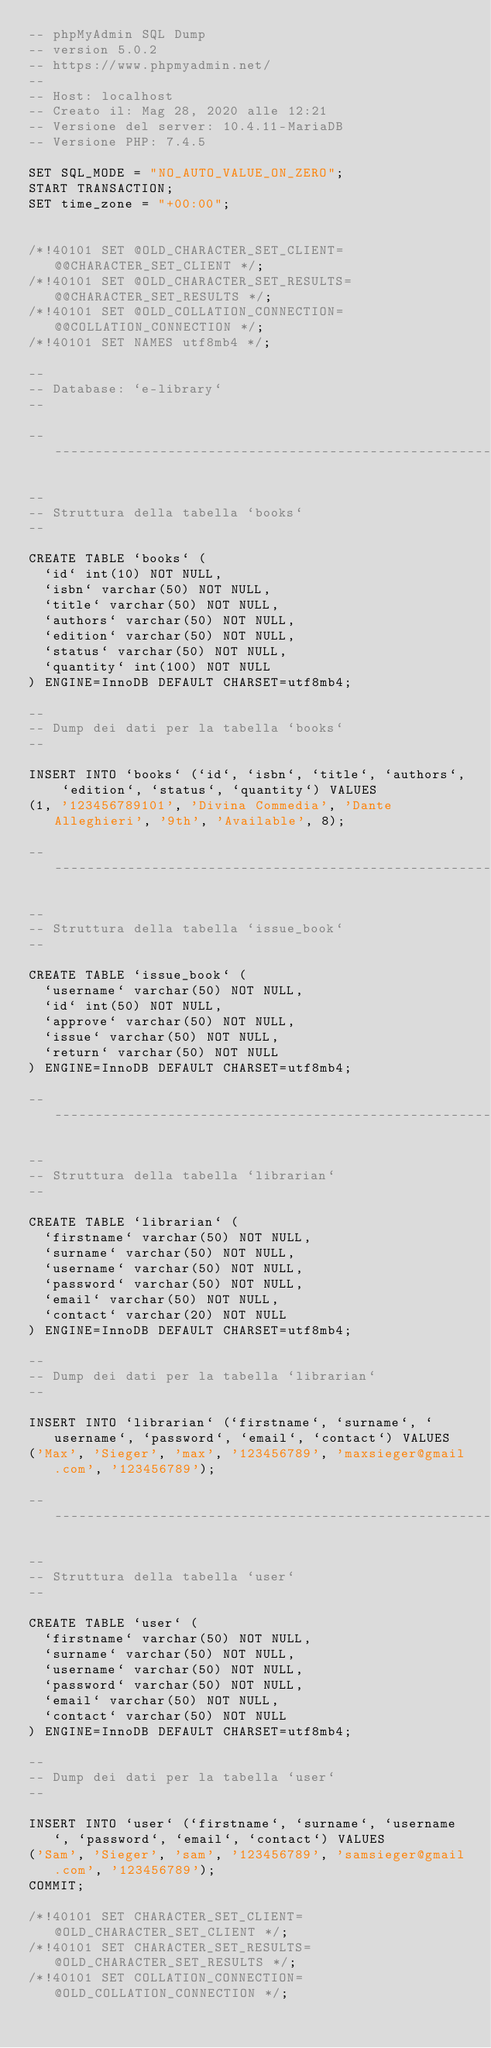Convert code to text. <code><loc_0><loc_0><loc_500><loc_500><_SQL_>-- phpMyAdmin SQL Dump
-- version 5.0.2
-- https://www.phpmyadmin.net/
--
-- Host: localhost
-- Creato il: Mag 28, 2020 alle 12:21
-- Versione del server: 10.4.11-MariaDB
-- Versione PHP: 7.4.5

SET SQL_MODE = "NO_AUTO_VALUE_ON_ZERO";
START TRANSACTION;
SET time_zone = "+00:00";


/*!40101 SET @OLD_CHARACTER_SET_CLIENT=@@CHARACTER_SET_CLIENT */;
/*!40101 SET @OLD_CHARACTER_SET_RESULTS=@@CHARACTER_SET_RESULTS */;
/*!40101 SET @OLD_COLLATION_CONNECTION=@@COLLATION_CONNECTION */;
/*!40101 SET NAMES utf8mb4 */;

--
-- Database: `e-library`
--

-- --------------------------------------------------------

--
-- Struttura della tabella `books`
--

CREATE TABLE `books` (
  `id` int(10) NOT NULL,
  `isbn` varchar(50) NOT NULL,
  `title` varchar(50) NOT NULL,
  `authors` varchar(50) NOT NULL,
  `edition` varchar(50) NOT NULL,
  `status` varchar(50) NOT NULL,
  `quantity` int(100) NOT NULL
) ENGINE=InnoDB DEFAULT CHARSET=utf8mb4;

--
-- Dump dei dati per la tabella `books`
--

INSERT INTO `books` (`id`, `isbn`, `title`, `authors`, `edition`, `status`, `quantity`) VALUES
(1, '123456789101', 'Divina Commedia', 'Dante Alleghieri', '9th', 'Available', 8);

-- --------------------------------------------------------

--
-- Struttura della tabella `issue_book`
--

CREATE TABLE `issue_book` (
  `username` varchar(50) NOT NULL,
  `id` int(50) NOT NULL,
  `approve` varchar(50) NOT NULL,
  `issue` varchar(50) NOT NULL,
  `return` varchar(50) NOT NULL
) ENGINE=InnoDB DEFAULT CHARSET=utf8mb4;

-- --------------------------------------------------------

--
-- Struttura della tabella `librarian`
--

CREATE TABLE `librarian` (
  `firstname` varchar(50) NOT NULL,
  `surname` varchar(50) NOT NULL,
  `username` varchar(50) NOT NULL,
  `password` varchar(50) NOT NULL,
  `email` varchar(50) NOT NULL,
  `contact` varchar(20) NOT NULL
) ENGINE=InnoDB DEFAULT CHARSET=utf8mb4;

--
-- Dump dei dati per la tabella `librarian`
--

INSERT INTO `librarian` (`firstname`, `surname`, `username`, `password`, `email`, `contact`) VALUES
('Max', 'Sieger', 'max', '123456789', 'maxsieger@gmail.com', '123456789');

-- --------------------------------------------------------

--
-- Struttura della tabella `user`
--

CREATE TABLE `user` (
  `firstname` varchar(50) NOT NULL,
  `surname` varchar(50) NOT NULL,
  `username` varchar(50) NOT NULL,
  `password` varchar(50) NOT NULL,
  `email` varchar(50) NOT NULL,
  `contact` varchar(50) NOT NULL
) ENGINE=InnoDB DEFAULT CHARSET=utf8mb4;

--
-- Dump dei dati per la tabella `user`
--

INSERT INTO `user` (`firstname`, `surname`, `username`, `password`, `email`, `contact`) VALUES
('Sam', 'Sieger', 'sam', '123456789', 'samsieger@gmail.com', '123456789');
COMMIT;

/*!40101 SET CHARACTER_SET_CLIENT=@OLD_CHARACTER_SET_CLIENT */;
/*!40101 SET CHARACTER_SET_RESULTS=@OLD_CHARACTER_SET_RESULTS */;
/*!40101 SET COLLATION_CONNECTION=@OLD_COLLATION_CONNECTION */;
</code> 